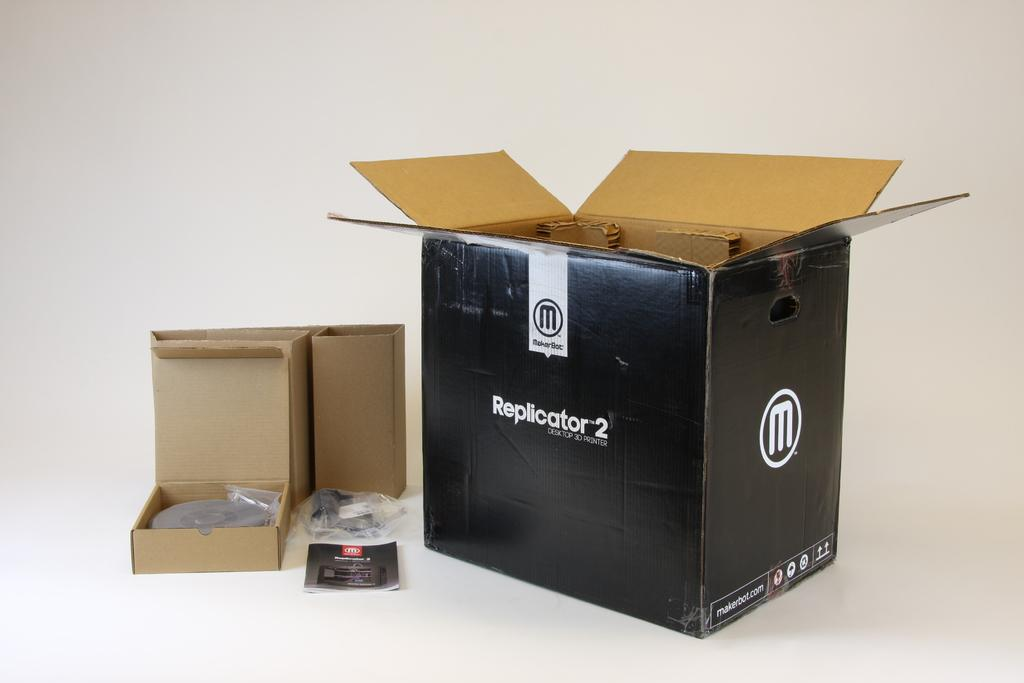Provide a one-sentence caption for the provided image. An open Replicator 2 box and its components. 